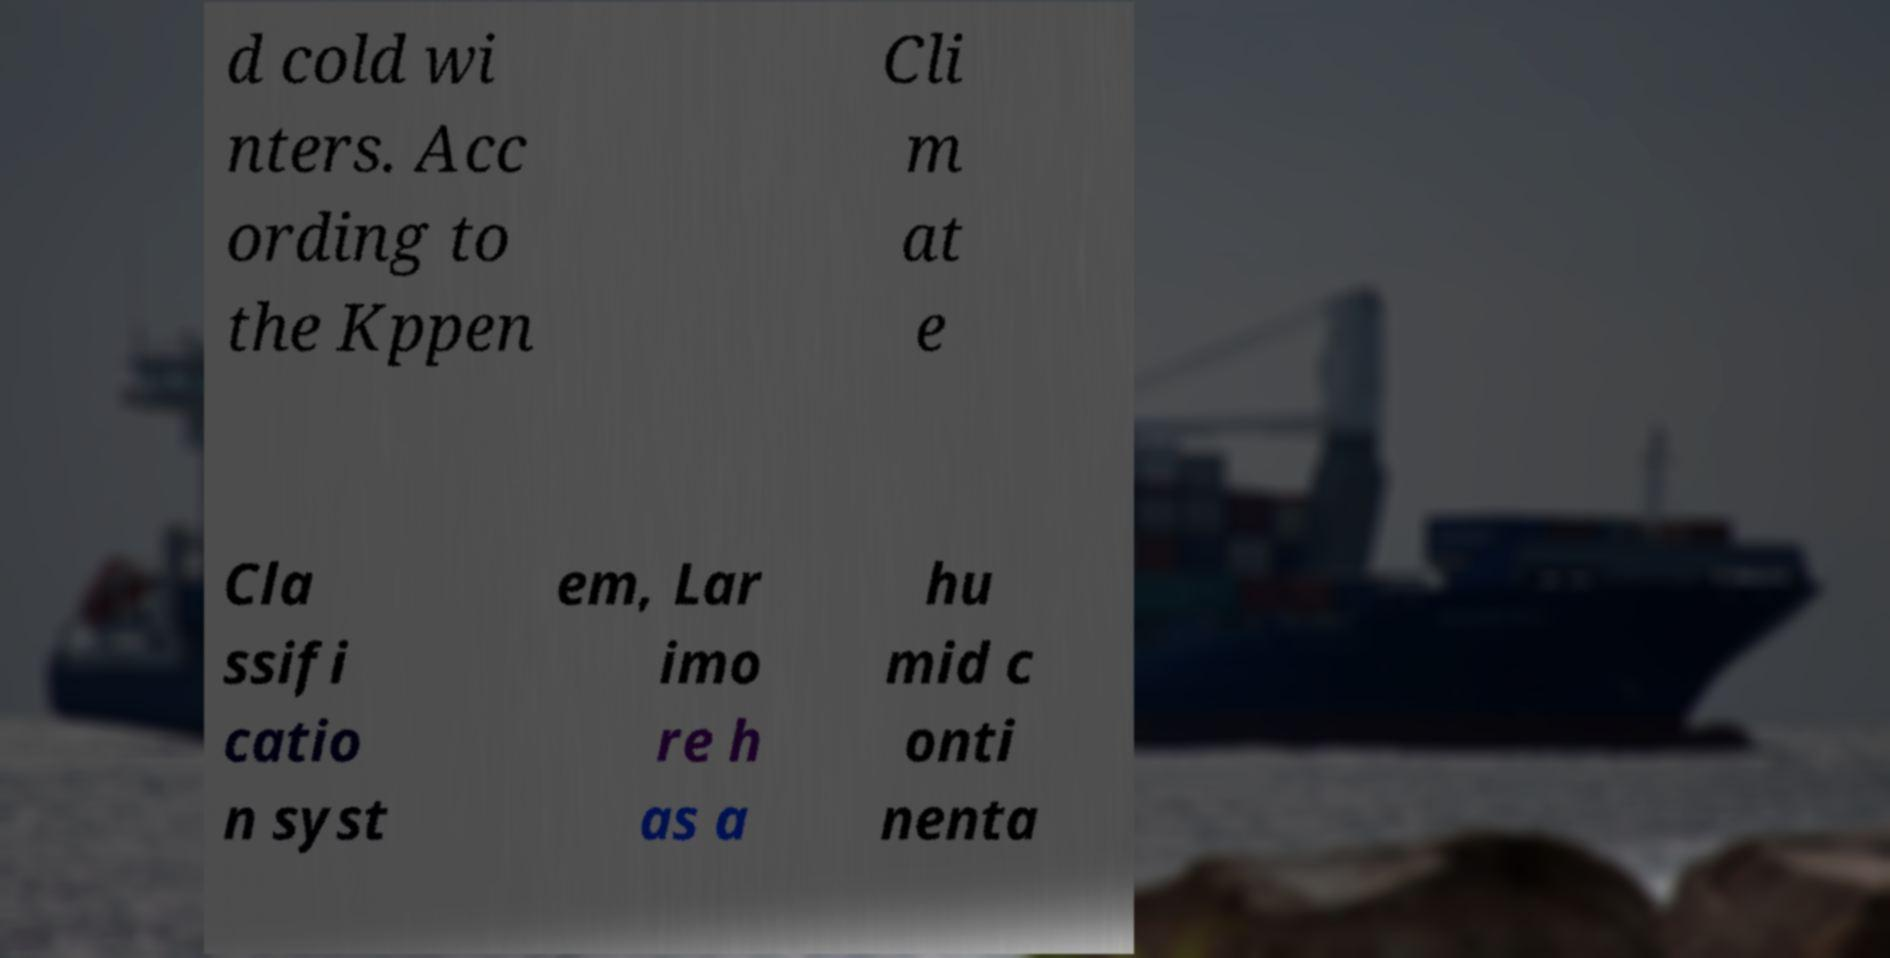Can you read and provide the text displayed in the image?This photo seems to have some interesting text. Can you extract and type it out for me? d cold wi nters. Acc ording to the Kppen Cli m at e Cla ssifi catio n syst em, Lar imo re h as a hu mid c onti nenta 